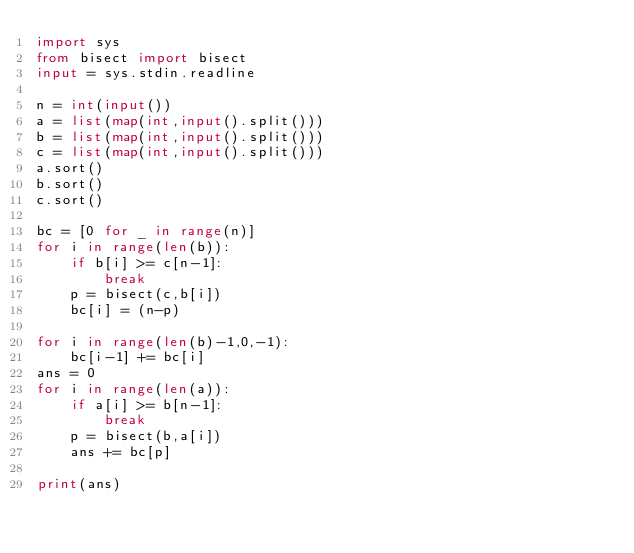Convert code to text. <code><loc_0><loc_0><loc_500><loc_500><_Python_>import sys
from bisect import bisect
input = sys.stdin.readline

n = int(input())
a = list(map(int,input().split()))
b = list(map(int,input().split()))
c = list(map(int,input().split()))
a.sort()
b.sort()
c.sort()

bc = [0 for _ in range(n)]
for i in range(len(b)):
    if b[i] >= c[n-1]:
        break
    p = bisect(c,b[i])
    bc[i] = (n-p)

for i in range(len(b)-1,0,-1):
    bc[i-1] += bc[i]
ans = 0
for i in range(len(a)):
    if a[i] >= b[n-1]:
        break
    p = bisect(b,a[i])
    ans += bc[p]

print(ans)</code> 